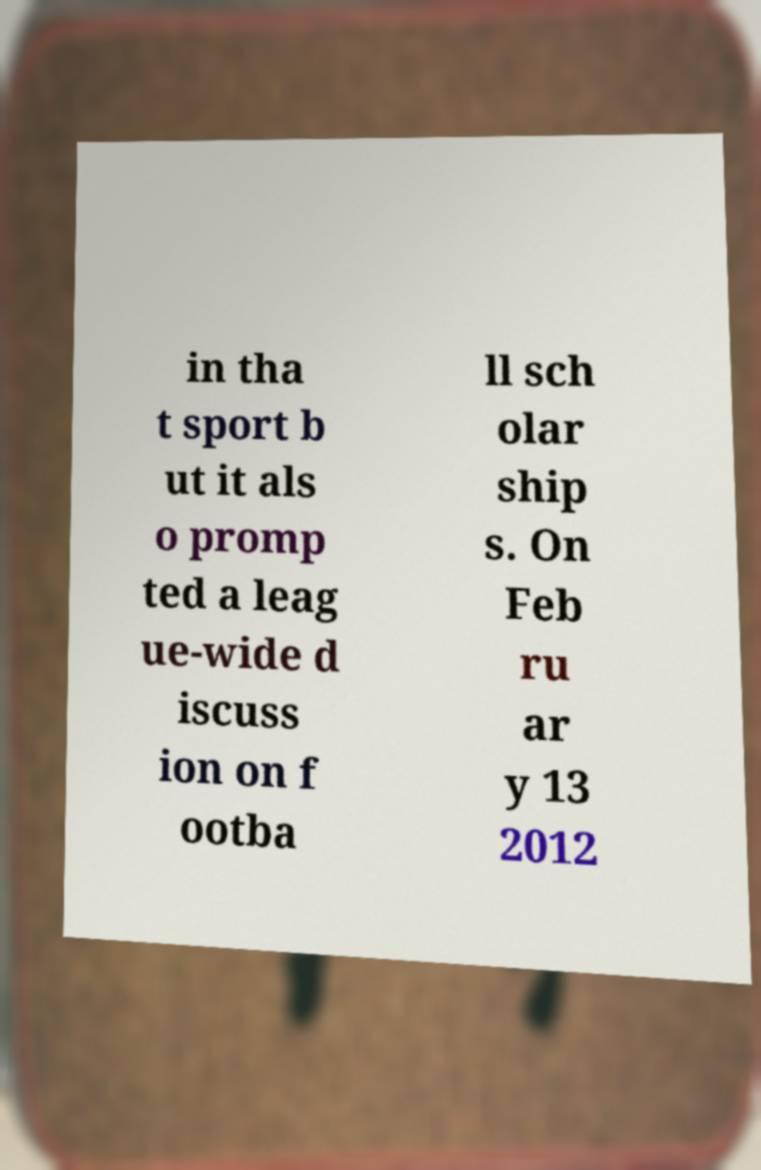There's text embedded in this image that I need extracted. Can you transcribe it verbatim? in tha t sport b ut it als o promp ted a leag ue-wide d iscuss ion on f ootba ll sch olar ship s. On Feb ru ar y 13 2012 